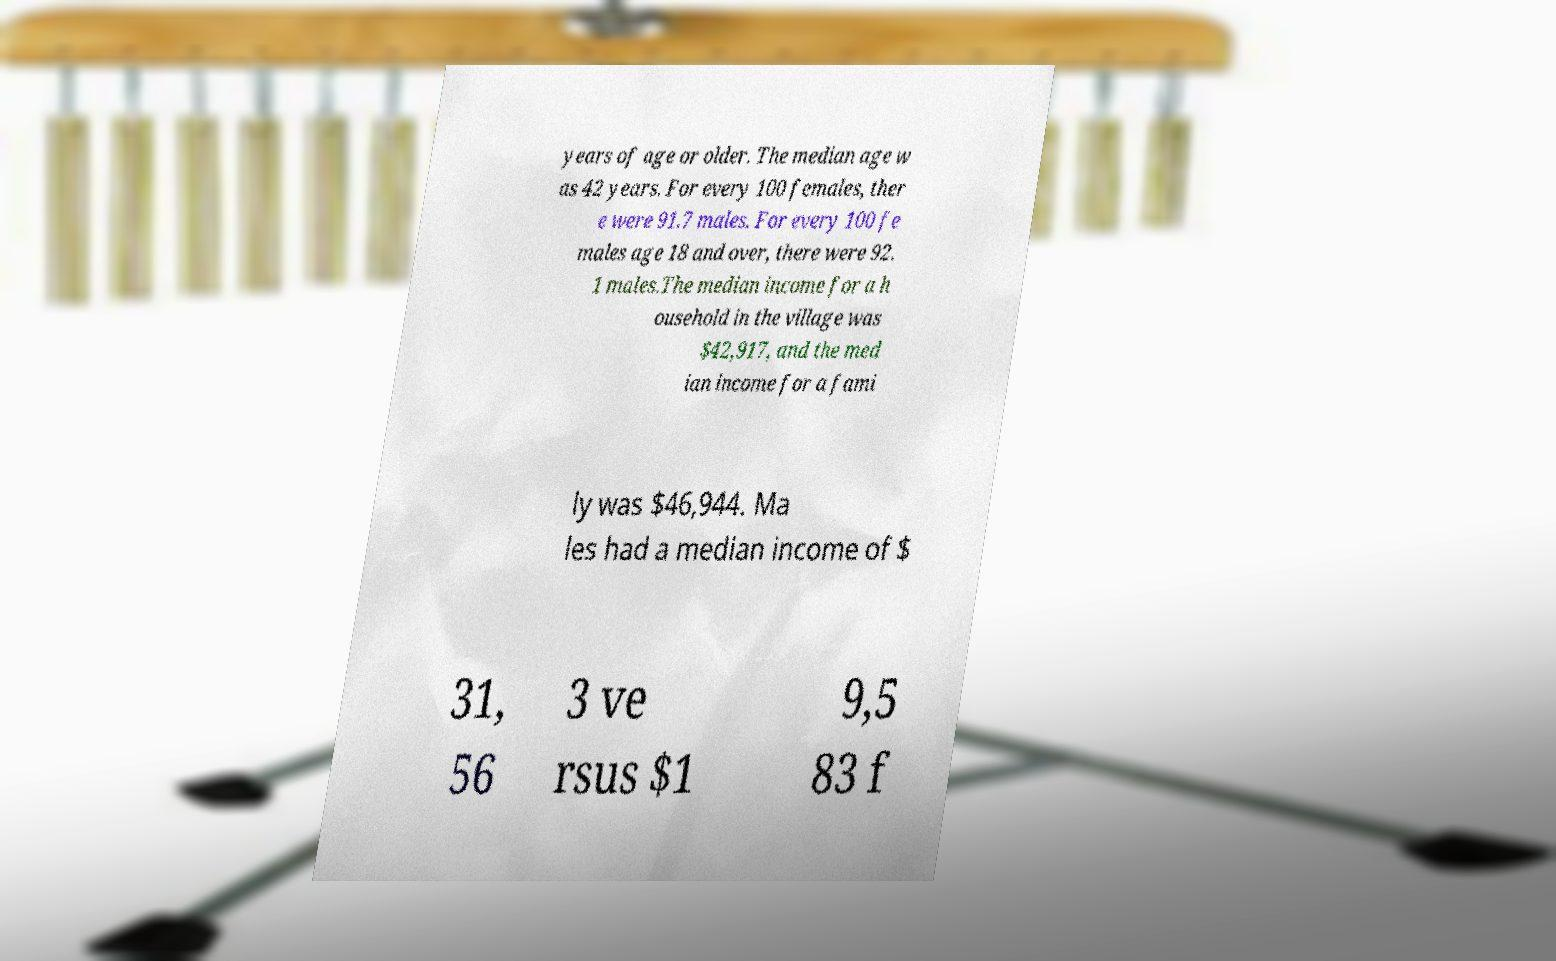Can you accurately transcribe the text from the provided image for me? years of age or older. The median age w as 42 years. For every 100 females, ther e were 91.7 males. For every 100 fe males age 18 and over, there were 92. 1 males.The median income for a h ousehold in the village was $42,917, and the med ian income for a fami ly was $46,944. Ma les had a median income of $ 31, 56 3 ve rsus $1 9,5 83 f 